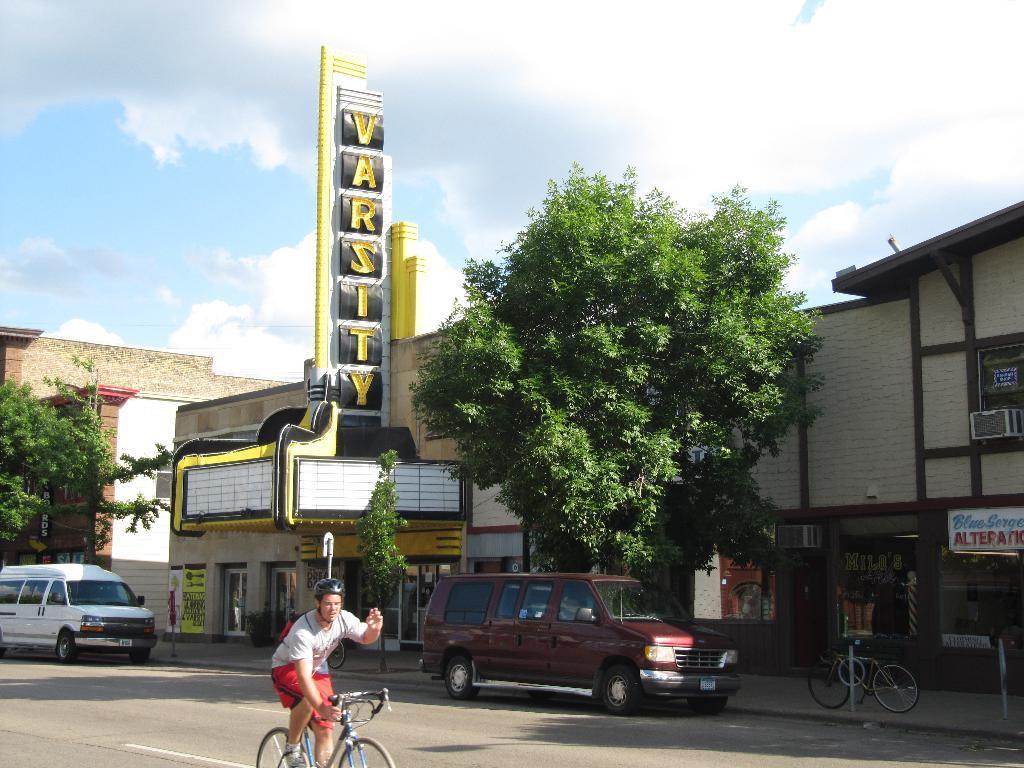How would you summarize this image in a sentence or two? Here we can see a man riding a bicycle on the road and there are two vehicles on the road. In the background there are trees,buildings,hoardings,poles,a bicycle at the pole,AC and clouds in the sky. 